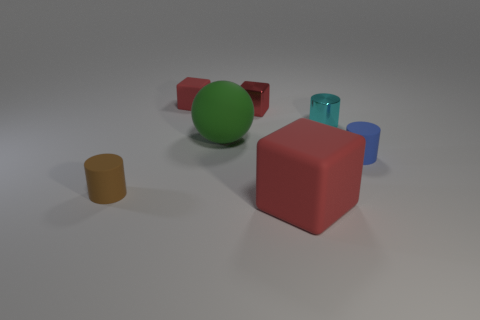Is the shape of the tiny matte object that is on the left side of the small red matte cube the same as the tiny metallic thing to the right of the big red rubber thing?
Your response must be concise. Yes. The tiny thing that is both behind the metallic cylinder and on the left side of the large ball is what color?
Your response must be concise. Red. Are there any metal cubes of the same color as the small rubber cube?
Offer a very short reply. Yes. There is a rubber cube that is in front of the tiny brown matte cylinder; what color is it?
Your response must be concise. Red. There is a red shiny cube that is behind the large green rubber sphere; is there a red object left of it?
Your answer should be compact. Yes. There is a small matte block; is its color the same as the rubber cube that is in front of the tiny brown cylinder?
Provide a short and direct response. Yes. Are there any tiny blue cylinders made of the same material as the green sphere?
Make the answer very short. Yes. How many large green objects are there?
Your response must be concise. 1. There is a big object that is on the right side of the large object that is behind the blue matte thing; what is its material?
Provide a succinct answer. Rubber. What color is the large ball that is made of the same material as the large red cube?
Offer a very short reply. Green. 